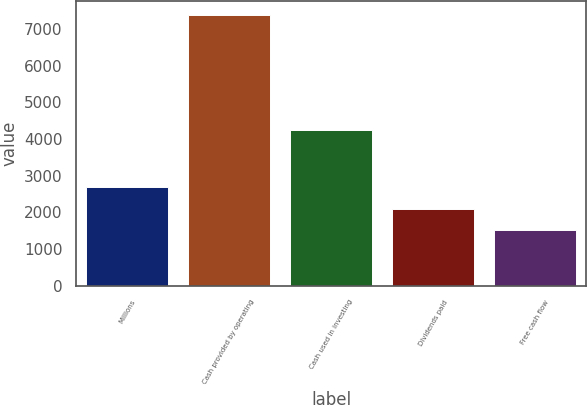Convert chart. <chart><loc_0><loc_0><loc_500><loc_500><bar_chart><fcel>Millions<fcel>Cash provided by operating<fcel>Cash used in investing<fcel>Dividends paid<fcel>Free cash flow<nl><fcel>2680.2<fcel>7385<fcel>4249<fcel>2092.1<fcel>1504<nl></chart> 